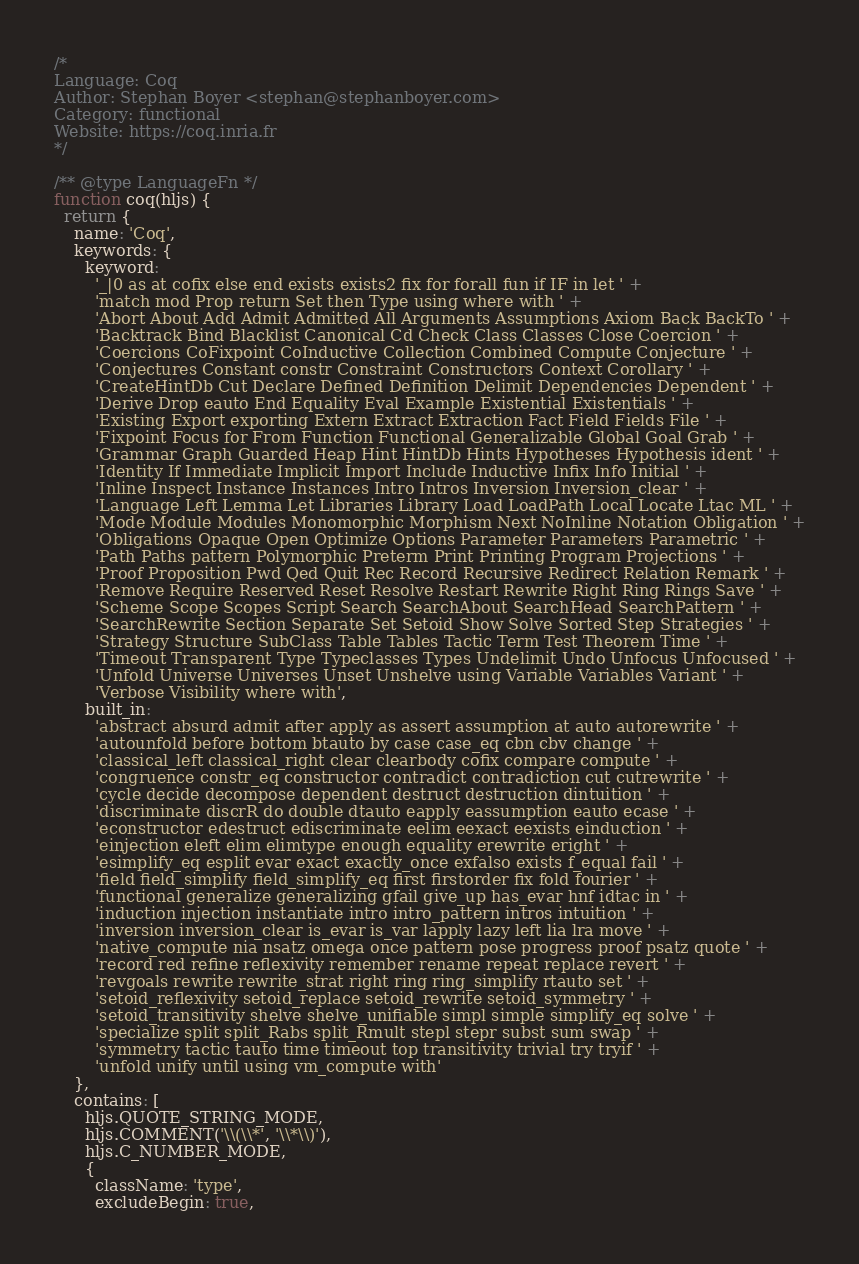Convert code to text. <code><loc_0><loc_0><loc_500><loc_500><_JavaScript_>/*
Language: Coq
Author: Stephan Boyer <stephan@stephanboyer.com>
Category: functional
Website: https://coq.inria.fr
*/

/** @type LanguageFn */
function coq(hljs) {
  return {
    name: 'Coq',
    keywords: {
      keyword:
        '_|0 as at cofix else end exists exists2 fix for forall fun if IF in let ' +
        'match mod Prop return Set then Type using where with ' +
        'Abort About Add Admit Admitted All Arguments Assumptions Axiom Back BackTo ' +
        'Backtrack Bind Blacklist Canonical Cd Check Class Classes Close Coercion ' +
        'Coercions CoFixpoint CoInductive Collection Combined Compute Conjecture ' +
        'Conjectures Constant constr Constraint Constructors Context Corollary ' +
        'CreateHintDb Cut Declare Defined Definition Delimit Dependencies Dependent ' +
        'Derive Drop eauto End Equality Eval Example Existential Existentials ' +
        'Existing Export exporting Extern Extract Extraction Fact Field Fields File ' +
        'Fixpoint Focus for From Function Functional Generalizable Global Goal Grab ' +
        'Grammar Graph Guarded Heap Hint HintDb Hints Hypotheses Hypothesis ident ' +
        'Identity If Immediate Implicit Import Include Inductive Infix Info Initial ' +
        'Inline Inspect Instance Instances Intro Intros Inversion Inversion_clear ' +
        'Language Left Lemma Let Libraries Library Load LoadPath Local Locate Ltac ML ' +
        'Mode Module Modules Monomorphic Morphism Next NoInline Notation Obligation ' +
        'Obligations Opaque Open Optimize Options Parameter Parameters Parametric ' +
        'Path Paths pattern Polymorphic Preterm Print Printing Program Projections ' +
        'Proof Proposition Pwd Qed Quit Rec Record Recursive Redirect Relation Remark ' +
        'Remove Require Reserved Reset Resolve Restart Rewrite Right Ring Rings Save ' +
        'Scheme Scope Scopes Script Search SearchAbout SearchHead SearchPattern ' +
        'SearchRewrite Section Separate Set Setoid Show Solve Sorted Step Strategies ' +
        'Strategy Structure SubClass Table Tables Tactic Term Test Theorem Time ' +
        'Timeout Transparent Type Typeclasses Types Undelimit Undo Unfocus Unfocused ' +
        'Unfold Universe Universes Unset Unshelve using Variable Variables Variant ' +
        'Verbose Visibility where with',
      built_in:
        'abstract absurd admit after apply as assert assumption at auto autorewrite ' +
        'autounfold before bottom btauto by case case_eq cbn cbv change ' +
        'classical_left classical_right clear clearbody cofix compare compute ' +
        'congruence constr_eq constructor contradict contradiction cut cutrewrite ' +
        'cycle decide decompose dependent destruct destruction dintuition ' +
        'discriminate discrR do double dtauto eapply eassumption eauto ecase ' +
        'econstructor edestruct ediscriminate eelim eexact eexists einduction ' +
        'einjection eleft elim elimtype enough equality erewrite eright ' +
        'esimplify_eq esplit evar exact exactly_once exfalso exists f_equal fail ' +
        'field field_simplify field_simplify_eq first firstorder fix fold fourier ' +
        'functional generalize generalizing gfail give_up has_evar hnf idtac in ' +
        'induction injection instantiate intro intro_pattern intros intuition ' +
        'inversion inversion_clear is_evar is_var lapply lazy left lia lra move ' +
        'native_compute nia nsatz omega once pattern pose progress proof psatz quote ' +
        'record red refine reflexivity remember rename repeat replace revert ' +
        'revgoals rewrite rewrite_strat right ring ring_simplify rtauto set ' +
        'setoid_reflexivity setoid_replace setoid_rewrite setoid_symmetry ' +
        'setoid_transitivity shelve shelve_unifiable simpl simple simplify_eq solve ' +
        'specialize split split_Rabs split_Rmult stepl stepr subst sum swap ' +
        'symmetry tactic tauto time timeout top transitivity trivial try tryif ' +
        'unfold unify until using vm_compute with'
    },
    contains: [
      hljs.QUOTE_STRING_MODE,
      hljs.COMMENT('\\(\\*', '\\*\\)'),
      hljs.C_NUMBER_MODE,
      {
        className: 'type',
        excludeBegin: true,</code> 